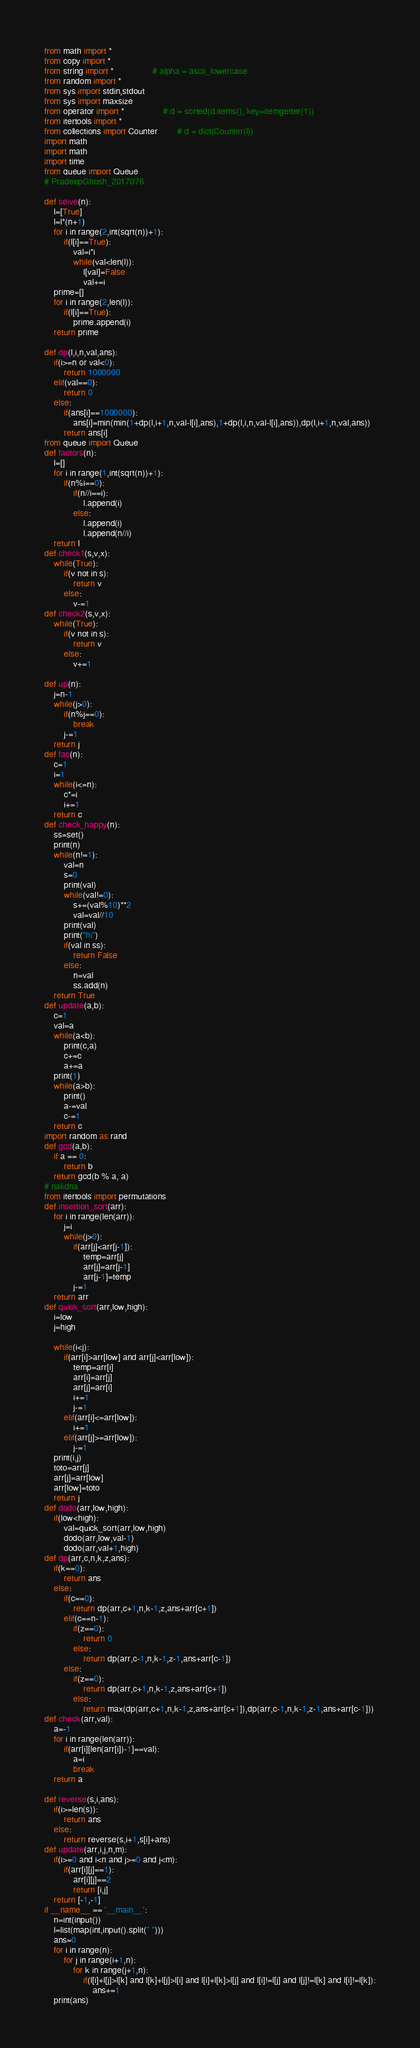<code> <loc_0><loc_0><loc_500><loc_500><_Python_>from math import *
from copy import *
from string import *				# alpha = ascii_lowercase
from random import *
from sys import stdin,stdout
from sys import maxsize
from operator import *				# d = sorted(d.items(), key=itemgetter(1))
from itertools import *
from collections import Counter		# d = dict(Counter(l))
import math
import math
import time
from queue import Queue
# PradeepGhosh_2017076

def seive(n):
	l=[True]
	l=l*(n+1)
	for i in range(2,int(sqrt(n))+1):
		if(l[i]==True):
			val=i*i
			while(val<len(l)):
				l[val]=False
				val+=i
	prime=[]
	for i in range(2,len(l)):
		if(l[i]==True):
			prime.append(i)
	return prime

def dp(l,i,n,val,ans):
	if(i>=n or val<0):
		return 1000000
	elif(val==0):
		return 0
	else:
		if(ans[i]==1000000):
			ans[i]=min(min(1+dp(l,i+1,n,val-l[i],ans),1+dp(l,i,n,val-l[i],ans)),dp(l,i+1,n,val,ans))
		return ans[i]
from queue import Queue
def factors(n):
	l=[]
	for i in range(1,int(sqrt(n))+1):
		if(n%i==0):
			if(n//i==i):
				l.append(i)
			else:
				l.append(i)
				l.append(n//i)
	return l
def check1(s,v,x):
	while(True):
		if(v not in s):
			return v
		else:
			v-=1
def check2(s,v,x):
	while(True):
		if(v not in s):
			return v
		else:
			v+=1

def up(n):
	j=n-1
	while(j>0):
		if(n%j==0):
			break
		j-=1
	return j		
def fac(n):
	c=1
	i=1
	while(i<=n):
		c*=i
		i+=1
	return c
def check_happy(n):
	ss=set()
	print(n)
	while(n!=1):
		val=n
		s=0
		print(val)
		while(val!=0):
			s+=(val%10)**2
			val=val//10
		print(val)
		print("hi")
		if(val in ss):
			return False
		else:
			n=val
			ss.add(n)
	return True
def update(a,b):
	c=1
	val=a
	while(a<b):
		print(c,a)
		c+=c
		a+=a
	print(1)
	while(a>b):
		print()
		a-=val
		c-=1
	return c
import random as rand
def gcd(a,b): 
    if a == 0: 
        return b 
    return gcd(b % a, a) 
# nakdna
from itertools import permutations
def insertion_sort(arr):
	for i in range(len(arr)):
		j=i
		while(j>0):
			if(arr[j]<arr[j-1]):
				temp=arr[j]
				arr[j]=arr[j-1]
				arr[j-1]=temp
			j-=1
	return arr
def quick_sort(arr,low,high):
	i=low
	j=high
	
	while(i<j):
		if(arr[i]>arr[low] and arr[j]<arr[low]):
			temp=arr[i]
			arr[i]=arr[j]
			arr[j]=arr[i]
			i+=1
			j-=1
		elif(arr[i]<=arr[low]):
			i+=1
		elif(arr[j]>=arr[low]):
			j-=1
	print(i,j)
	toto=arr[j]
	arr[j]=arr[low]
	arr[low]=toto
	return j
def dodo(arr,low,high):
	if(low<high):
		val=quick_sort(arr,low,high)
		dodo(arr,low,val-1)
		dodo(arr,val+1,high)
def dp(arr,c,n,k,z,ans):
	if(k==0):
		return ans
	else:
		if(c==0):
			return dp(arr,c+1,n,k-1,z,ans+arr[c+1])
		elif(c==n-1):
			if(z==0):
				return 0
			else:
				return dp(arr,c-1,n,k-1,z-1,ans+arr[c-1])
		else:
			if(z==0):
				return dp(arr,c+1,n,k-1,z,ans+arr[c+1])
			else:
				return max(dp(arr,c+1,n,k-1,z,ans+arr[c+1]),dp(arr,c-1,n,k-1,z-1,ans+arr[c-1]))
def check(arr,val):
	a=-1
	for i in range(len(arr)):
		if(arr[i][len(arr[i])-1]==val):
			a=i
			break
	return a

def reverse(s,i,ans):
	if(i>=len(s)):
		return ans
	else:
		return reverse(s,i+1,s[i]+ans)
def update(arr,i,j,n,m):
    if(i>=0 and i<n and j>=0 and j<m):
        if(arr[i][j]==1):
            arr[i][j]==2
            return [i,j]
    return [-1,-1]
if __name__ == '__main__':
	n=int(input())
	l=list(map(int,input().split(" ")))
	ans=0
	for i in range(n):
		for j in range(i+1,n):
			for k in range(j+1,n):
				if(l[i]+l[j]>l[k] and l[k]+l[j]>l[i] and l[i]+l[k]>l[j] and l[i]!=l[j] and l[j]!=l[k] and l[i]!=l[k]):
					ans+=1
	print(ans)</code> 